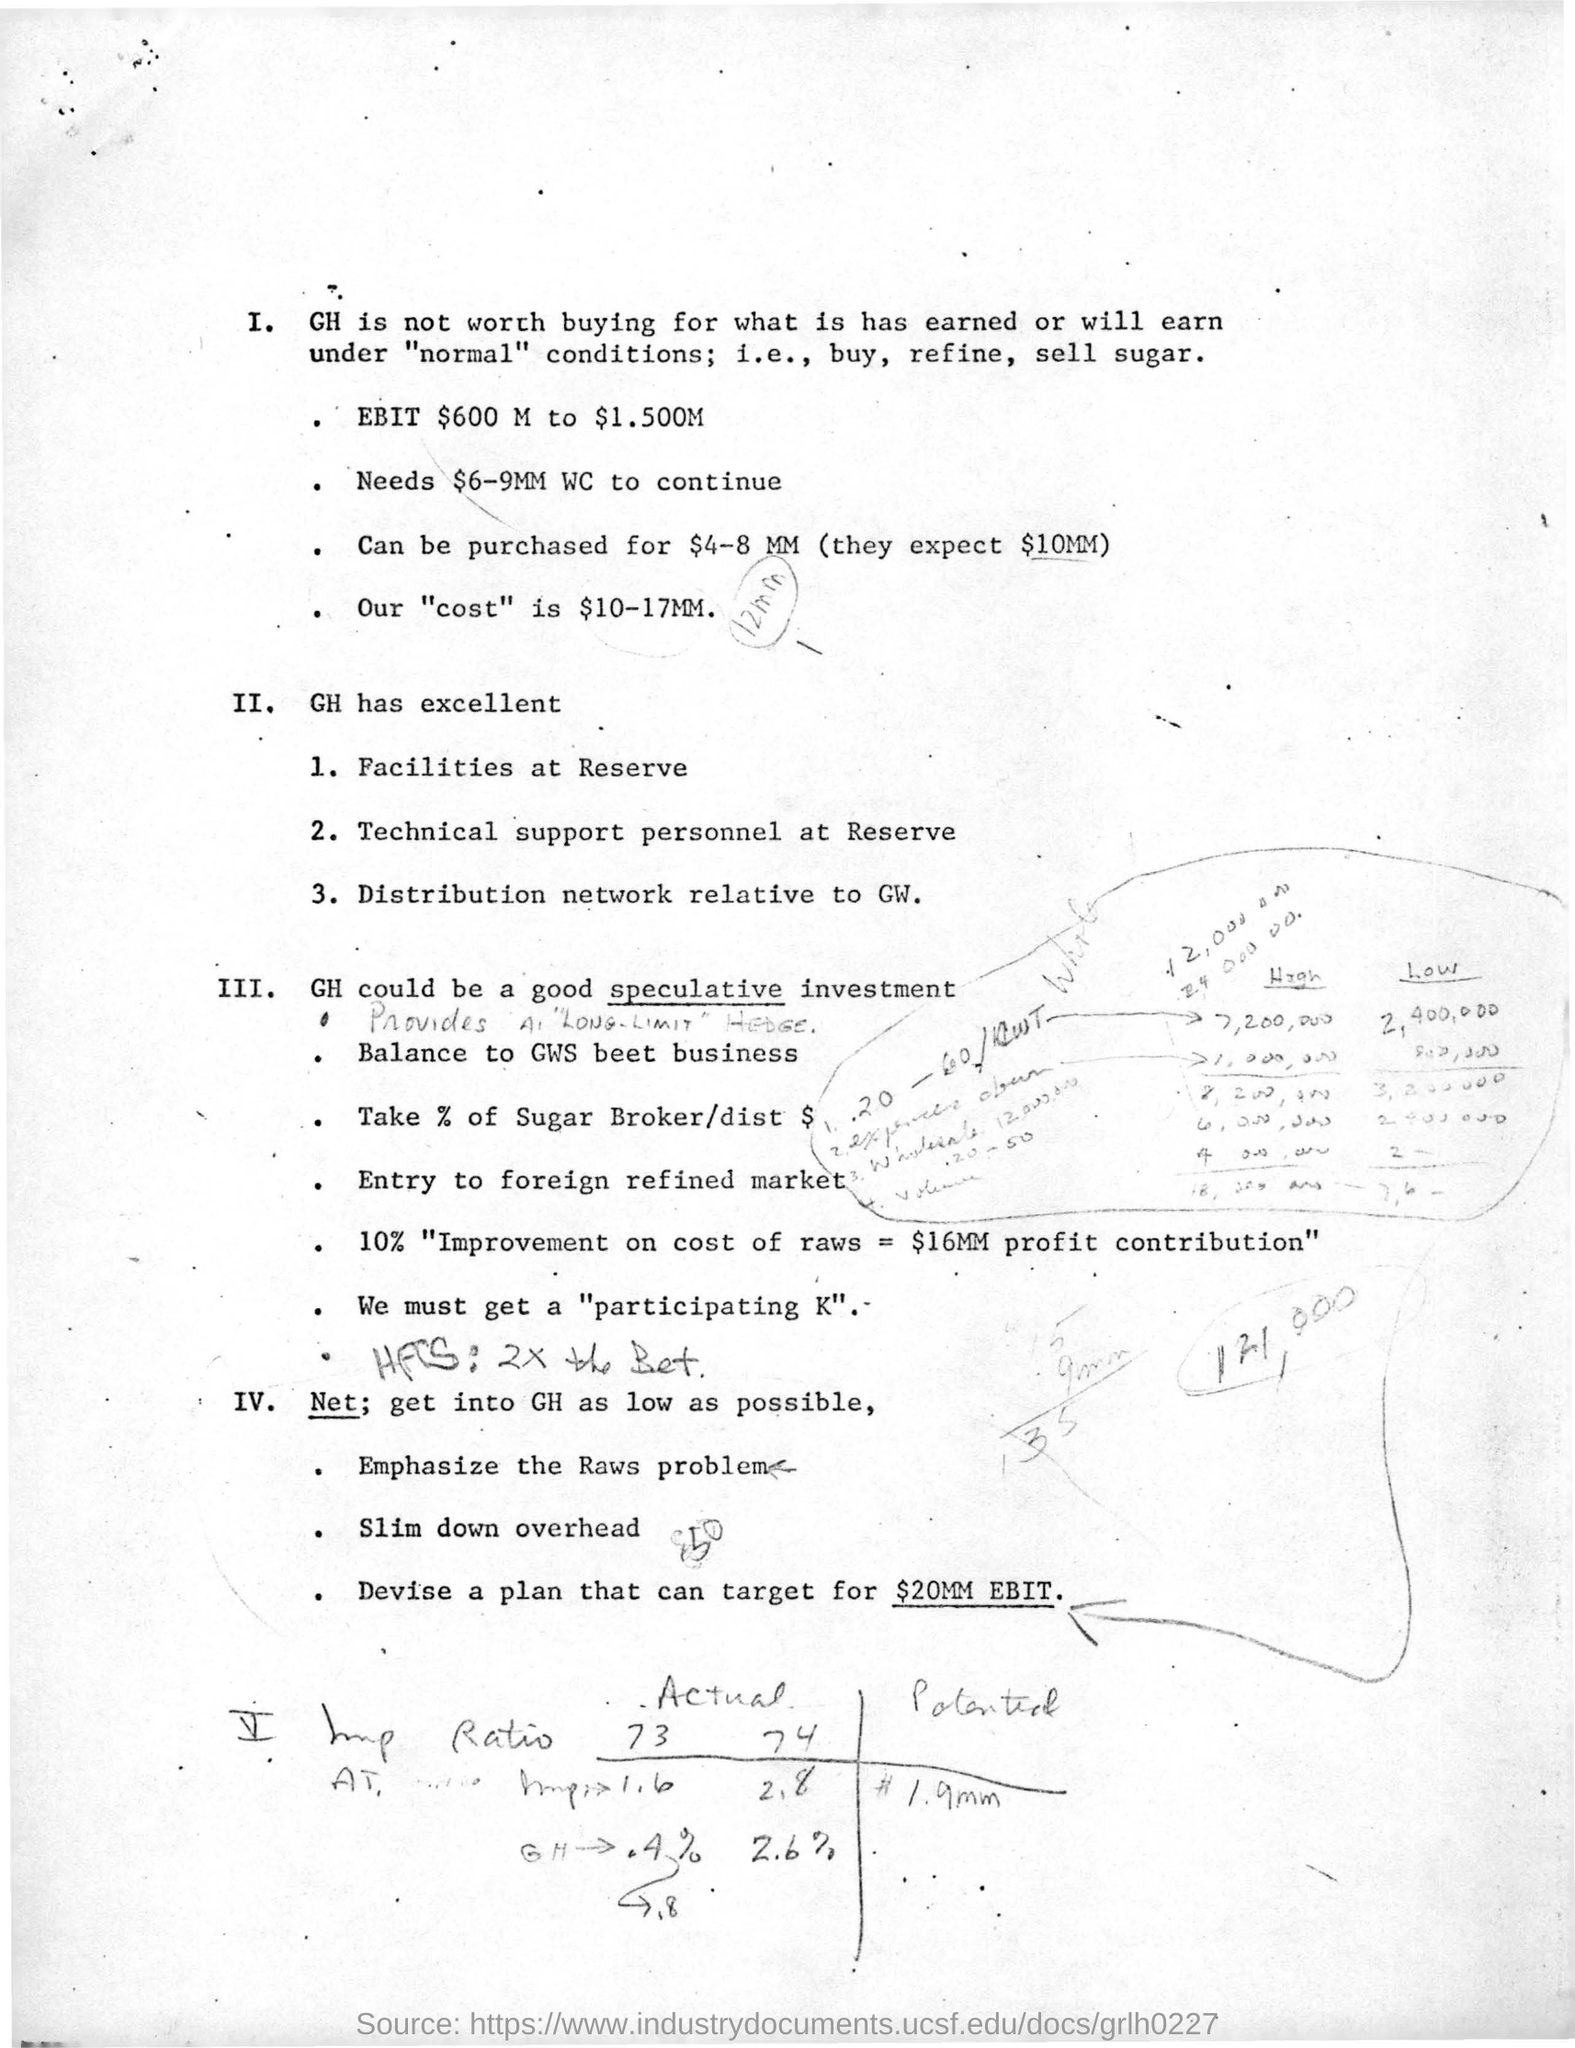Highlight a few significant elements in this photo. Our target with the Devise plan is to achieve an EBIT of $20 million. 